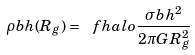Convert formula to latex. <formula><loc_0><loc_0><loc_500><loc_500>\rho b h ( R _ { g } ) = \ f h a l o \frac { \sigma b h ^ { 2 } } { 2 \pi G R _ { g } ^ { 2 } }</formula> 